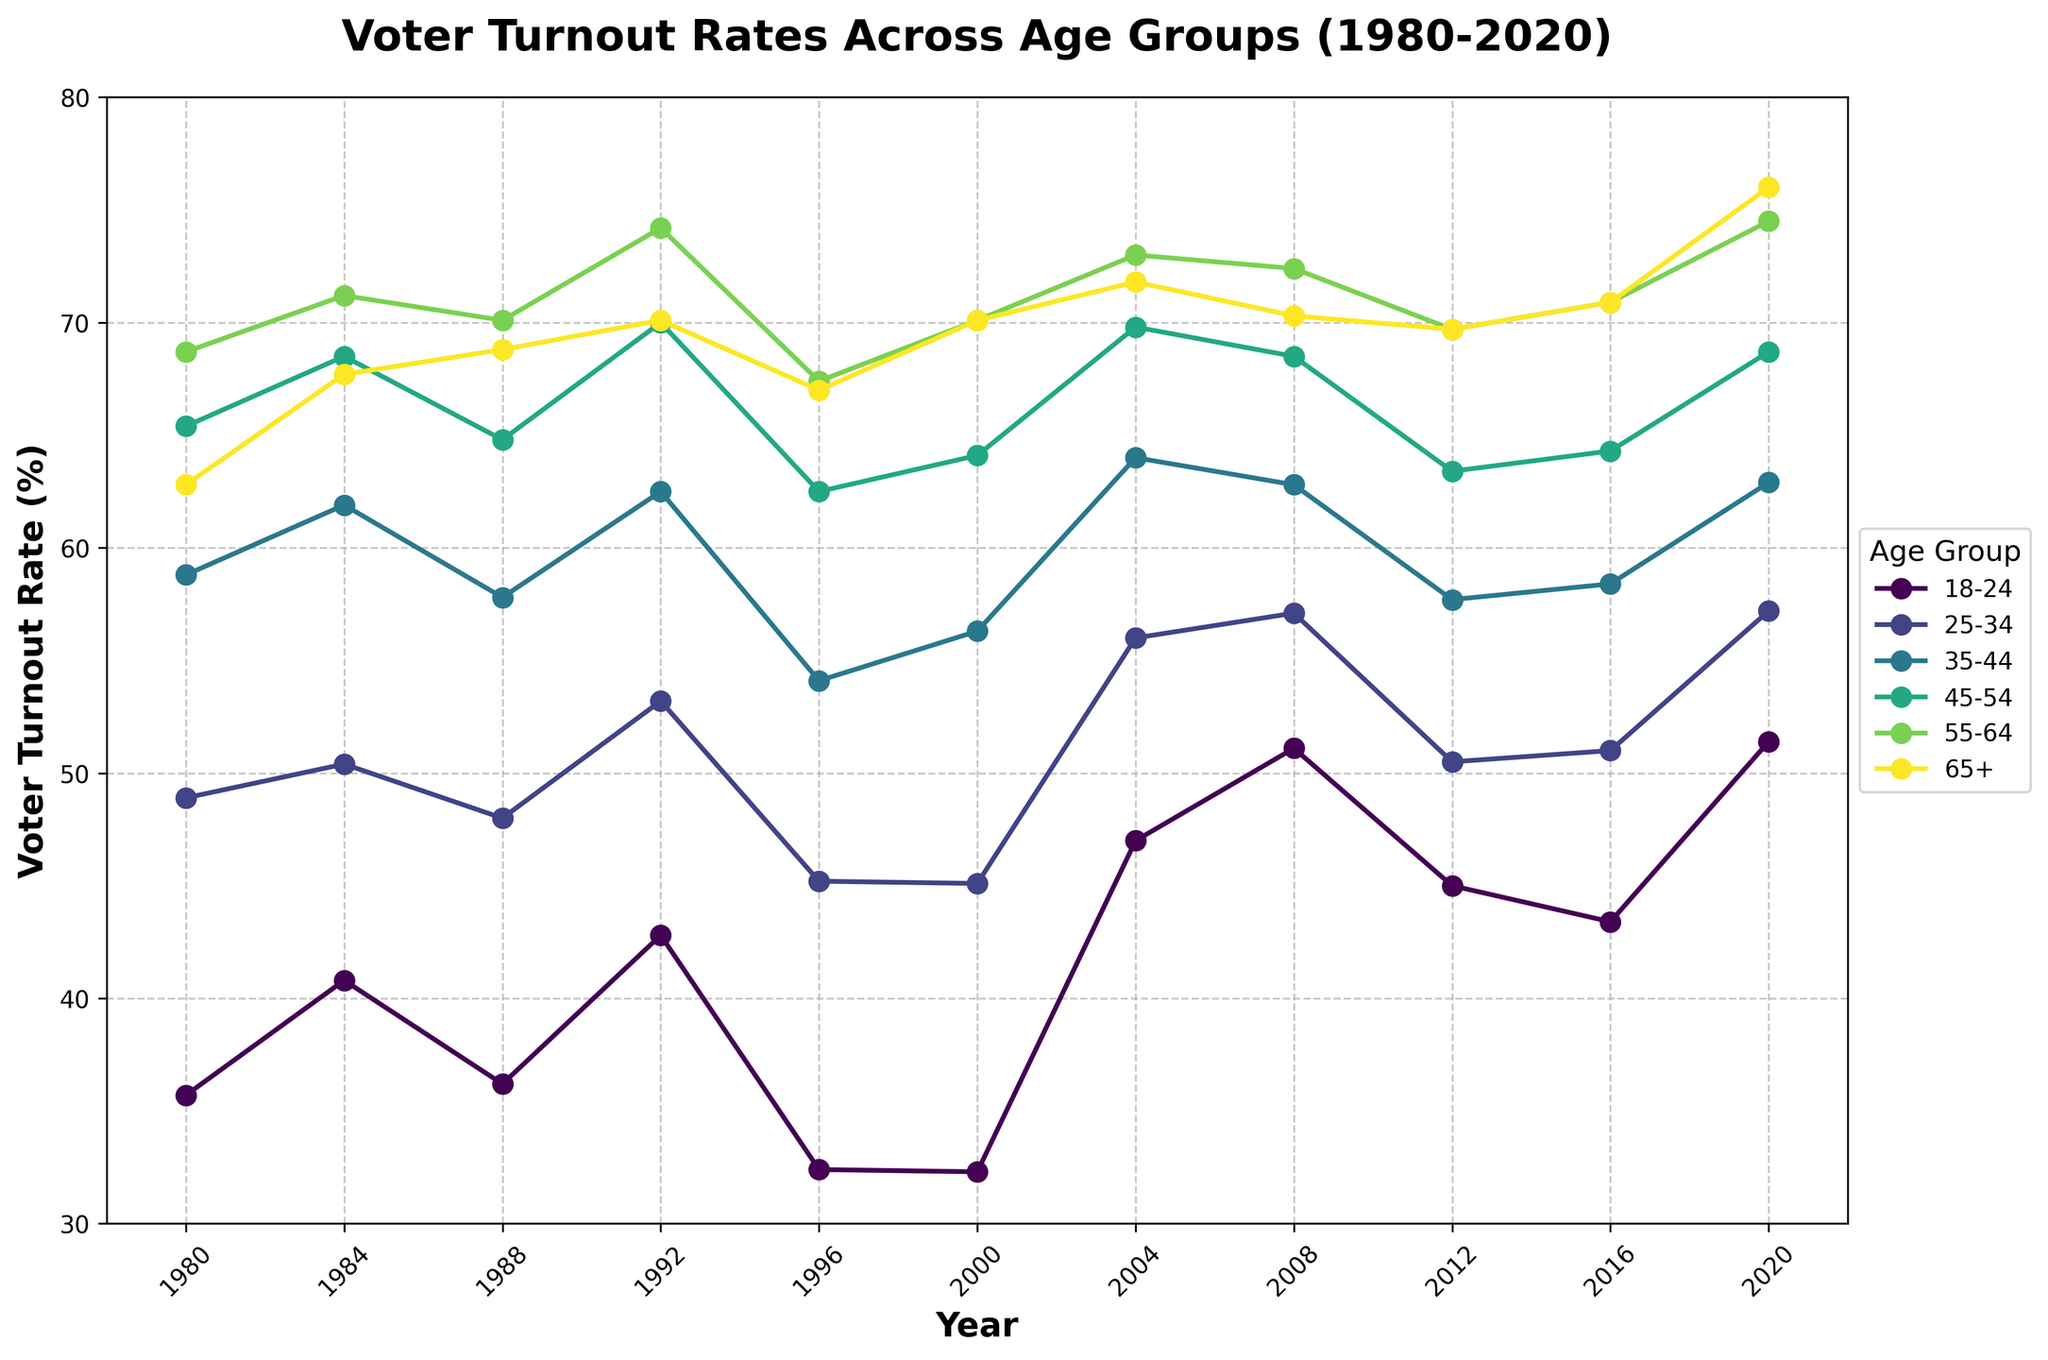What is the general trend of voter turnout rates for the 18-24 age group from 1980 to 2020? To identify the trend, observe the line representing the 18-24 age group. The line starts at 35.7% in 1980, rises and falls over the years, and reaches 51.4% in 2020. This shows an overall increasing trend with fluctuations.
Answer: Increasing Which age group had the highest voter turnout rate in 2020? Look at the endpoint of each age group's line in 2020. The 65+ age group has the highest turnout rate at 76.0%.
Answer: 65+ How did the voter turnout rate for 25-34 year-olds change between 1996 and 2020? Observe the data points for 25-34 year-olds in 1996 (45.2%) and 2020 (57.2%). The voter turnout rate increased by 57.2 - 45.2 = 12 percentage points.
Answer: Increased by 12 percentage points Which age group showed the most significant increase in voter turnout rate from 2000 to 2004? Compare the change between 2000 and 2004 for each age group. The 18-24 age group increased from 32.3% to 47.0%, a rise of 14.7 percentage points, the highest among all groups.
Answer: 18-24 What is the average voter turnout rate for the 55-64 age group over the four most recent elections (2008, 2012, 2016, 2020)? Calculate the average using the data from 2008 (72.4%), 2012 (69.7%), 2016 (70.9%), and 2020 (74.5%). The average is (72.4 + 69.7 + 70.9 + 74.5) / 4 = 71.88%.
Answer: 71.88% Did any age group experience a decrease in voter turnout from 1984 to 1988? Compare the turnout rates between 1984 and 1988 for all age groups. The 18-24 age group decreased from 40.8% to 36.2%.
Answer: Yes Which age group has consistently had a voter turnout rate above 60% since 1984? Look for age groups whose line never dips below the 60% mark from 1984 onward. The 55-64 age group fits this criterion.
Answer: 55-64 What was the voter turnout rate difference between the 45-54 and 18-24 age groups in 2008? Subtract the turnout rate of the 18-24 age group from the 45-54 age group in 2008. This is 68.5% - 51.1% = 17.4 percentage points.
Answer: 17.4 percentage points Between which two consecutive years did the 35-44 age group see its largest drop in voter turnout rate? Examine the data for the 35-44 age group to find the largest decline between consecutive years. The largest drop is between 2004 (64.0%) and 2008 (62.8%), where the difference is 64.0 - 62.8 = 1.2 percentage points.
Answer: Between 2004 and 2008 